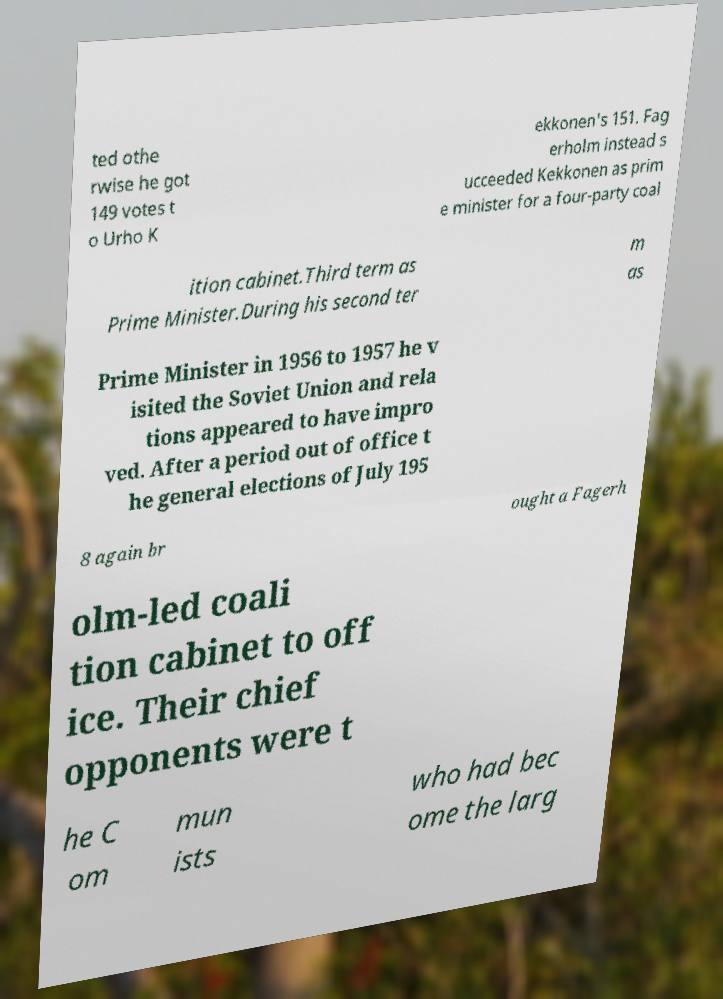Can you accurately transcribe the text from the provided image for me? ted othe rwise he got 149 votes t o Urho K ekkonen's 151. Fag erholm instead s ucceeded Kekkonen as prim e minister for a four-party coal ition cabinet.Third term as Prime Minister.During his second ter m as Prime Minister in 1956 to 1957 he v isited the Soviet Union and rela tions appeared to have impro ved. After a period out of office t he general elections of July 195 8 again br ought a Fagerh olm-led coali tion cabinet to off ice. Their chief opponents were t he C om mun ists who had bec ome the larg 